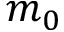<formula> <loc_0><loc_0><loc_500><loc_500>m _ { 0 }</formula> 